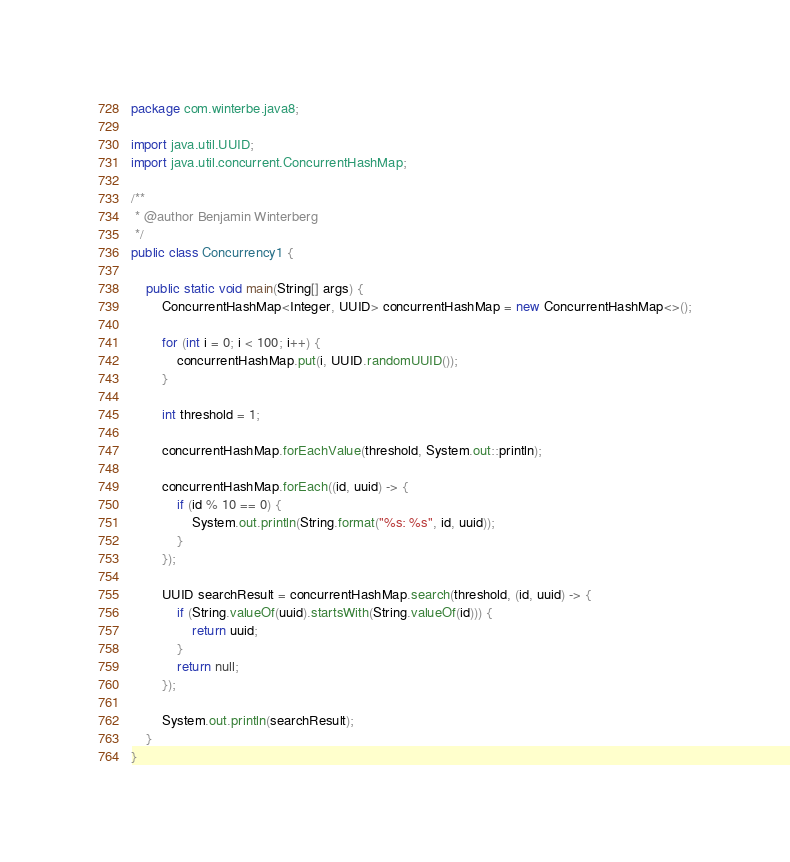Convert code to text. <code><loc_0><loc_0><loc_500><loc_500><_Java_>package com.winterbe.java8;

import java.util.UUID;
import java.util.concurrent.ConcurrentHashMap;

/**
 * @author Benjamin Winterberg
 */
public class Concurrency1 {

    public static void main(String[] args) {
        ConcurrentHashMap<Integer, UUID> concurrentHashMap = new ConcurrentHashMap<>();

        for (int i = 0; i < 100; i++) {
            concurrentHashMap.put(i, UUID.randomUUID());
        }

        int threshold = 1;

        concurrentHashMap.forEachValue(threshold, System.out::println);

        concurrentHashMap.forEach((id, uuid) -> {
            if (id % 10 == 0) {
                System.out.println(String.format("%s: %s", id, uuid));
            }
        });

        UUID searchResult = concurrentHashMap.search(threshold, (id, uuid) -> {
            if (String.valueOf(uuid).startsWith(String.valueOf(id))) {
                return uuid;
            }
            return null;
        });

        System.out.println(searchResult);
    }
}
</code> 